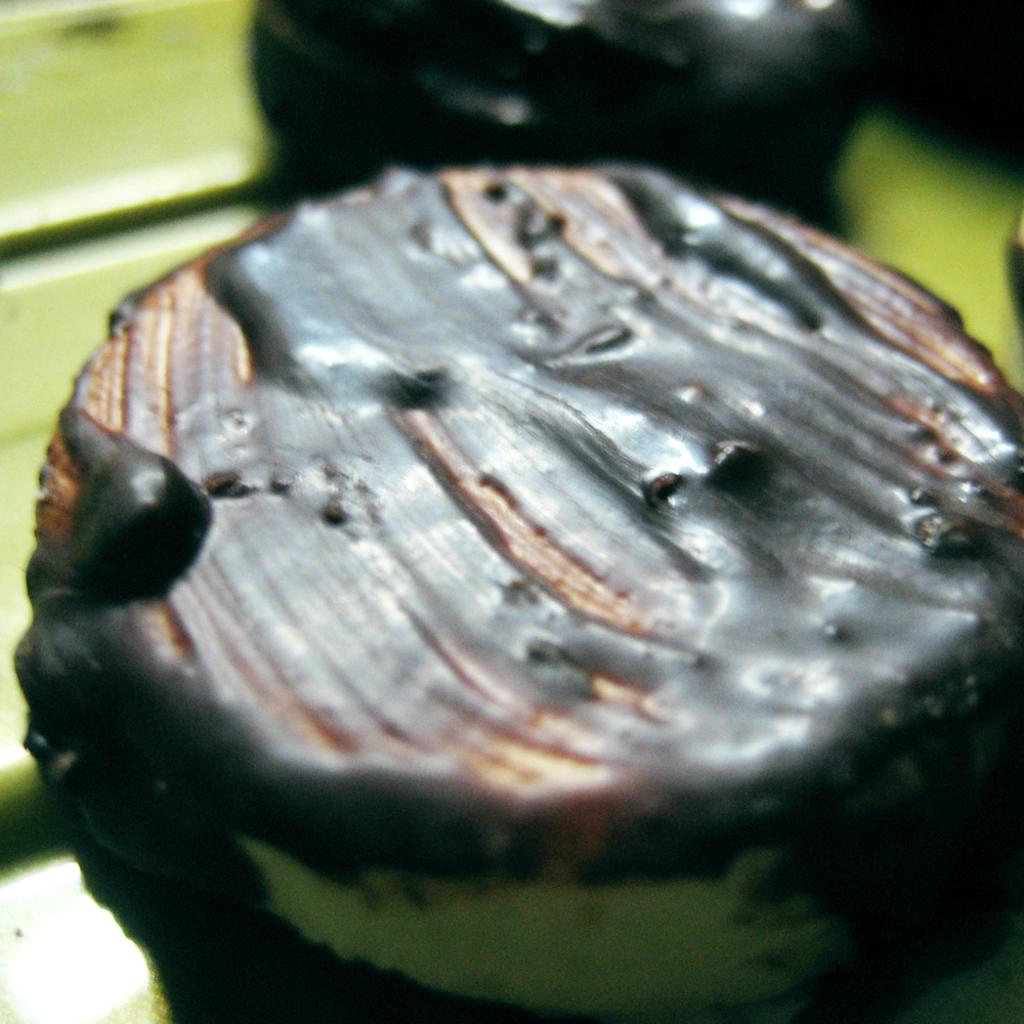What is the main subject of the image? There is a cake in the image. What type of topping is on the cake? The cake has chocolate cream on it. Can you describe the tiger that is sitting on top of the cake in the image? There is no tiger present on top of the cake in the image. 